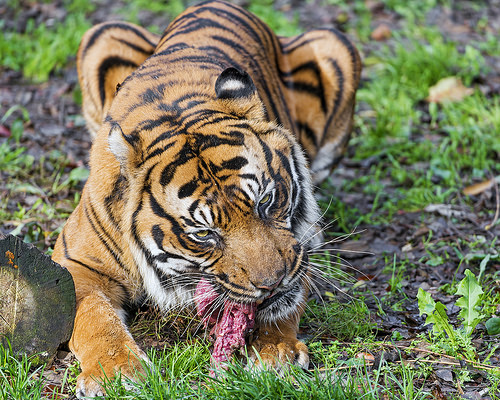<image>
Is there a tiger on the log? No. The tiger is not positioned on the log. They may be near each other, but the tiger is not supported by or resting on top of the log. 